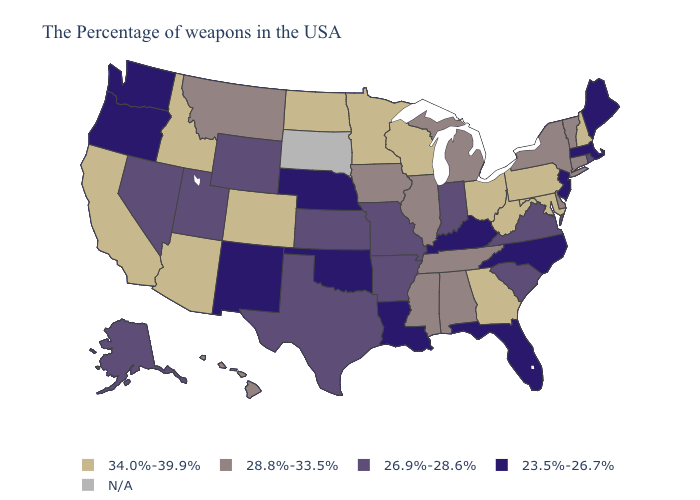Does the map have missing data?
Quick response, please. Yes. What is the value of Mississippi?
Give a very brief answer. 28.8%-33.5%. Name the states that have a value in the range 26.9%-28.6%?
Keep it brief. Rhode Island, Virginia, South Carolina, Indiana, Missouri, Arkansas, Kansas, Texas, Wyoming, Utah, Nevada, Alaska. What is the highest value in states that border New Jersey?
Write a very short answer. 34.0%-39.9%. What is the value of Michigan?
Concise answer only. 28.8%-33.5%. What is the value of Maine?
Give a very brief answer. 23.5%-26.7%. What is the lowest value in the South?
Keep it brief. 23.5%-26.7%. What is the lowest value in the USA?
Quick response, please. 23.5%-26.7%. Name the states that have a value in the range 26.9%-28.6%?
Answer briefly. Rhode Island, Virginia, South Carolina, Indiana, Missouri, Arkansas, Kansas, Texas, Wyoming, Utah, Nevada, Alaska. Name the states that have a value in the range 23.5%-26.7%?
Answer briefly. Maine, Massachusetts, New Jersey, North Carolina, Florida, Kentucky, Louisiana, Nebraska, Oklahoma, New Mexico, Washington, Oregon. Name the states that have a value in the range N/A?
Quick response, please. South Dakota. Among the states that border New Jersey , does Delaware have the lowest value?
Give a very brief answer. Yes. 